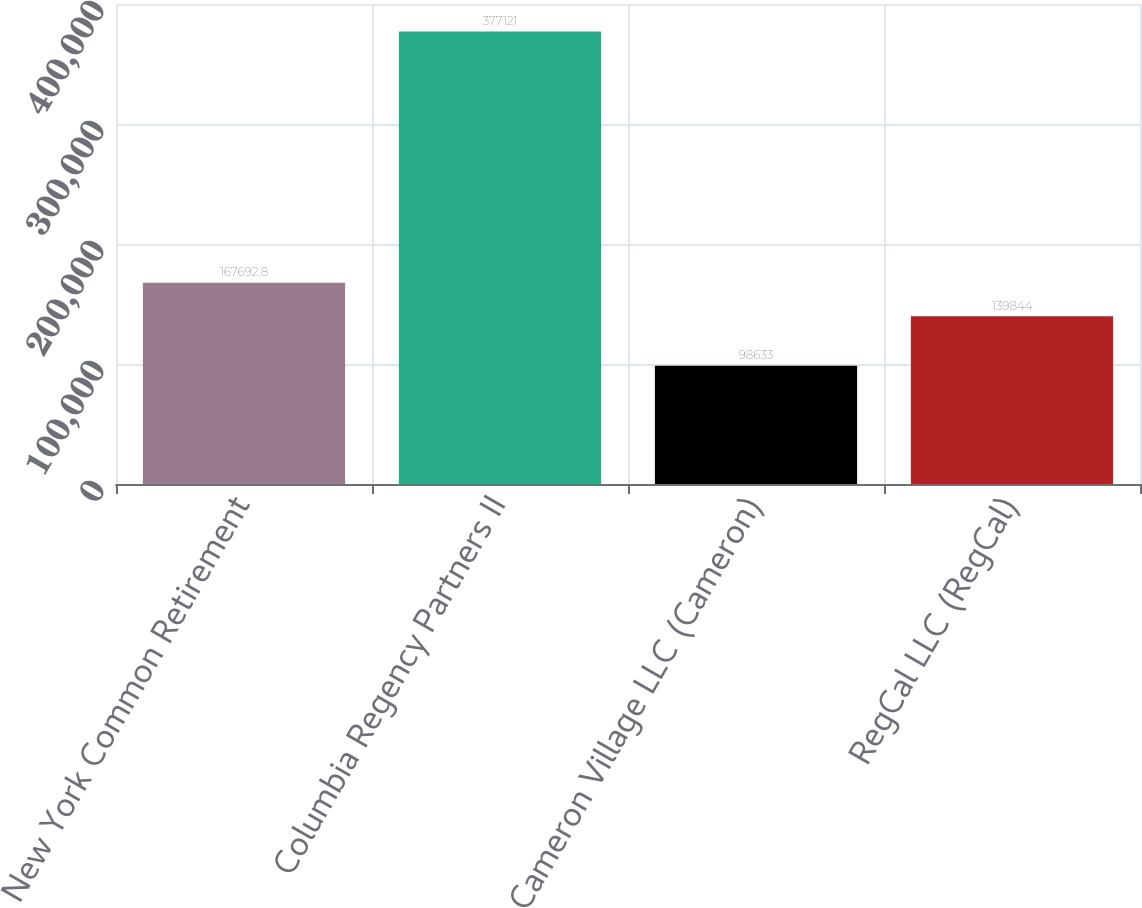Convert chart. <chart><loc_0><loc_0><loc_500><loc_500><bar_chart><fcel>New York Common Retirement<fcel>Columbia Regency Partners II<fcel>Cameron Village LLC (Cameron)<fcel>RegCal LLC (RegCal)<nl><fcel>167693<fcel>377121<fcel>98633<fcel>139844<nl></chart> 